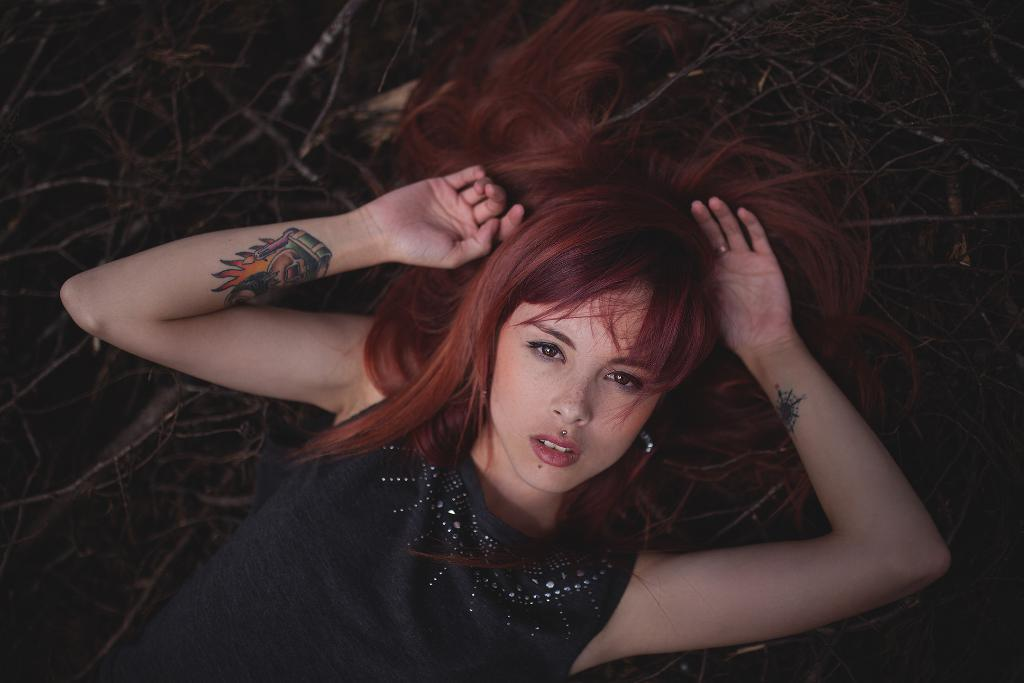Who is the main subject in the image? There is a girl in the image. What is the girl doing in the image? The girl is sleeping. What is the girl lying on in the image? The girl is lying on dry sticks. Can you describe any distinguishing features on the girl's body? There is a tattoo on the girl's right hand. What emotions are the boys expressing in the image? There are no boys present in the image, so it is not possible to determine their emotions. 